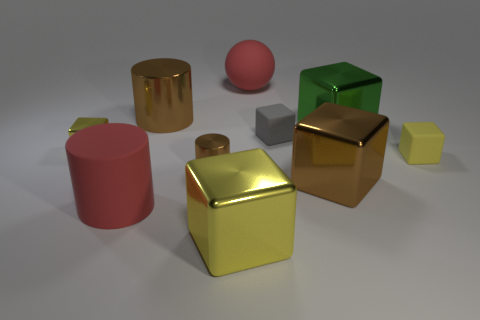Subtract all yellow blocks. How many were subtracted if there are1yellow blocks left? 2 Subtract all gray balls. How many yellow cubes are left? 3 Subtract 3 cubes. How many cubes are left? 3 Subtract all gray cubes. How many cubes are left? 5 Subtract all green cubes. How many cubes are left? 5 Subtract all cyan cylinders. Subtract all purple spheres. How many cylinders are left? 3 Subtract all cylinders. How many objects are left? 7 Subtract 1 brown blocks. How many objects are left? 9 Subtract all big cylinders. Subtract all big brown metallic blocks. How many objects are left? 7 Add 7 small yellow metallic objects. How many small yellow metallic objects are left? 8 